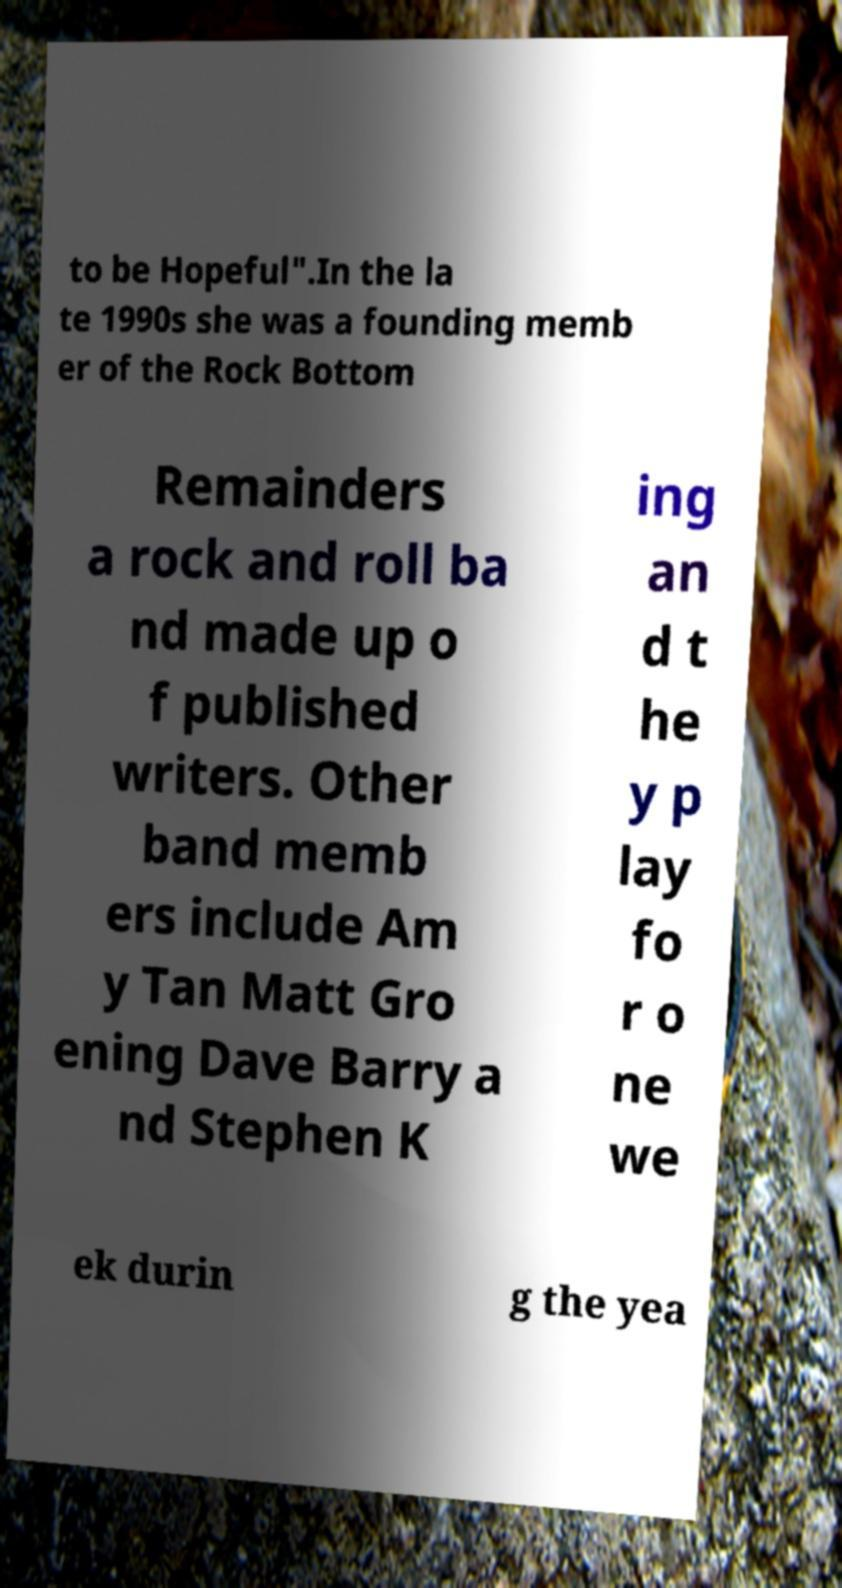Please identify and transcribe the text found in this image. to be Hopeful".In the la te 1990s she was a founding memb er of the Rock Bottom Remainders a rock and roll ba nd made up o f published writers. Other band memb ers include Am y Tan Matt Gro ening Dave Barry a nd Stephen K ing an d t he y p lay fo r o ne we ek durin g the yea 